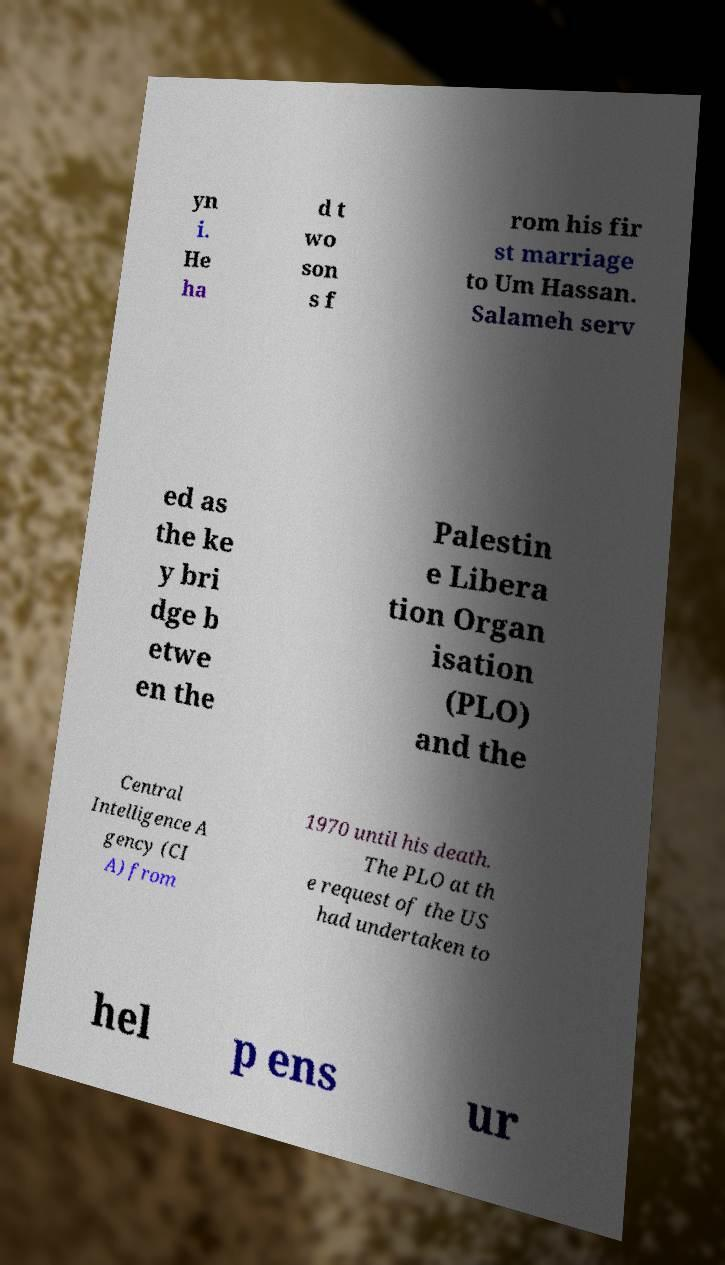Could you assist in decoding the text presented in this image and type it out clearly? yn i. He ha d t wo son s f rom his fir st marriage to Um Hassan. Salameh serv ed as the ke y bri dge b etwe en the Palestin e Libera tion Organ isation (PLO) and the Central Intelligence A gency (CI A) from 1970 until his death. The PLO at th e request of the US had undertaken to hel p ens ur 